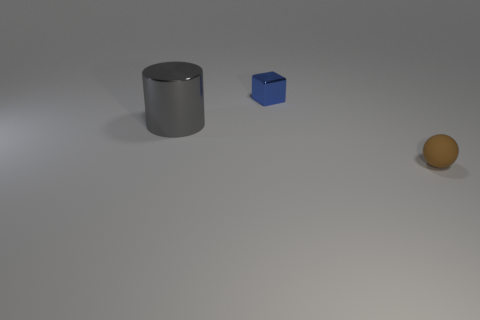There is a brown matte object that is the same size as the blue shiny thing; what is its shape?
Ensure brevity in your answer.  Sphere. How many other objects are the same color as the matte sphere?
Your response must be concise. 0. How big is the thing right of the metallic object that is to the right of the big gray thing?
Keep it short and to the point. Small. Are the tiny thing in front of the metallic block and the gray thing made of the same material?
Ensure brevity in your answer.  No. The small thing that is on the right side of the small blue metal cube has what shape?
Give a very brief answer. Sphere. How many blue objects are the same size as the shiny block?
Your answer should be compact. 0. What size is the matte ball?
Offer a terse response. Small. How many small objects are behind the big gray thing?
Ensure brevity in your answer.  1. There is a blue thing that is made of the same material as the large gray cylinder; what is its shape?
Provide a short and direct response. Cube. Are there fewer tiny matte spheres that are in front of the blue metal thing than tiny brown spheres that are behind the small sphere?
Make the answer very short. No. 